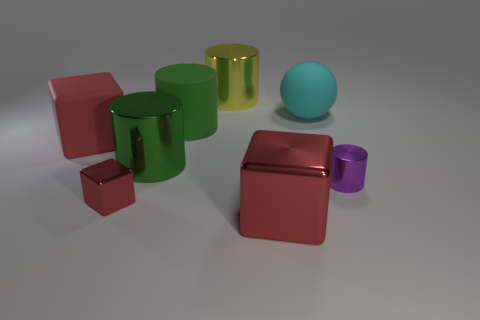Does the purple metal object have the same shape as the cyan object? no 